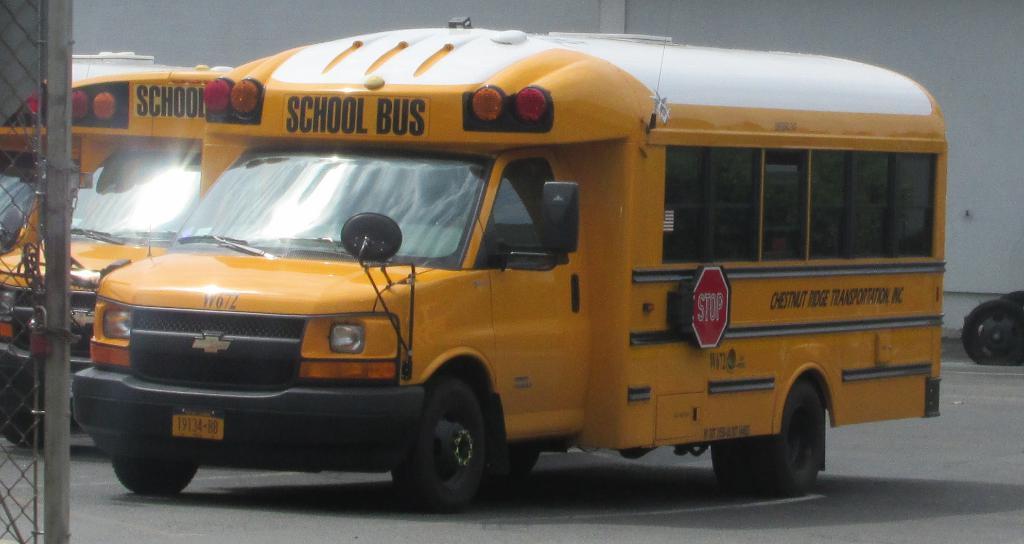How would you summarize this image in a sentence or two? In the image there are two school buses parked on the ground, they are of yellow color and there is a mesh in front of the buses, in the background there is a wall. 